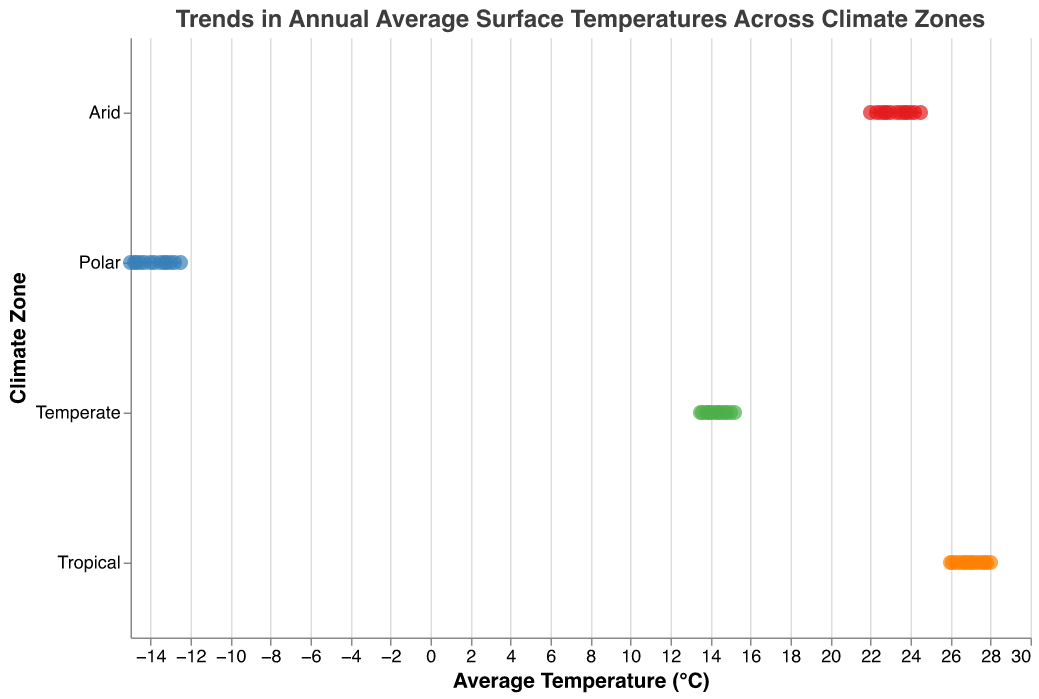What is the title of the plot? The title of the plot is displayed at the top and reads "Trends in Annual Average Surface Temperatures Across Climate Zones".
Answer: Trends in Annual Average Surface Temperatures Across Climate Zones Which Climate Zone has the highest average temperature in 2020? The Tropical Climate Zone has an average temperature of 28.0°C, which is the highest among the Climate Zones in 2020.
Answer: Tropical What is the temperature range for the Temperate Climate Zone from 1900 to 2020? The plot shows horizontal lines indicating the range. For the Temperate Climate Zone, it ranges from about 13.5°C to 15.2°C.
Answer: 13.5°C to 15.2°C What is the median temperature value for the Arid Climate Zone from 1900 to 2020? The median is the middle value. For the Arid Climate Zone, the temperatures range from 22.0°C to 24.5°C. The middle of this range is approximately (22.0 + 24.5)/2 = 23.25°C.
Answer: 23.25°C Between which years did the Tropical Climate Zone see the sharpest increase in average temperature? By examining the data points, the sharpest rise appears between 1960 (27.0°C) and 1970 (27.1°C) with an increase of 0.1°C.
Answer: 1960 to 1970 Which Climate Zone showed the highest increase in average temperature from 1900 to 2020? By comparing the starting and ending points of each Climate Zone: Tropical (2.0°C), Arid (2.5°C), Temperate (1.7°C), Polar (2.5°C). Both Arid and Polar zones increased by 2.5°C.
Answer: Arid and Polar What was the average temperature increase for the Polar Climate Zone over the entire period? The starting temperature in 1900 was -15.0°C and the ending temperature in 2020 was -12.5°C. The increase is -12.5 - (-15.0) = 2.5°C.
Answer: 2.5°C Which Climate Zone had the lowest average temperature in 1900? The lowest average temperature in 1900 is seen in the Polar Climate Zone at -15.0°C.
Answer: Polar Compare the average temperatures for Arid, Temperate, and Polar Climate Zones in 1950. Which zone had the highest and which had the lowest? The Arid zone is at 23.0°C, the Temperate zone is at 14.1°C, and the Polar zone is at -14.0°C. The highest is Arid at 23.0°C and the lowest is Polar at -14.0°C.
Answer: Highest: Arid, Lowest: Polar 